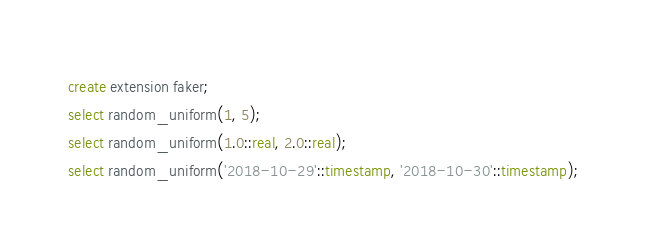<code> <loc_0><loc_0><loc_500><loc_500><_SQL_>create extension faker;
select random_uniform(1, 5);
select random_uniform(1.0::real, 2.0::real);
select random_uniform('2018-10-29'::timestamp, '2018-10-30'::timestamp);</code> 